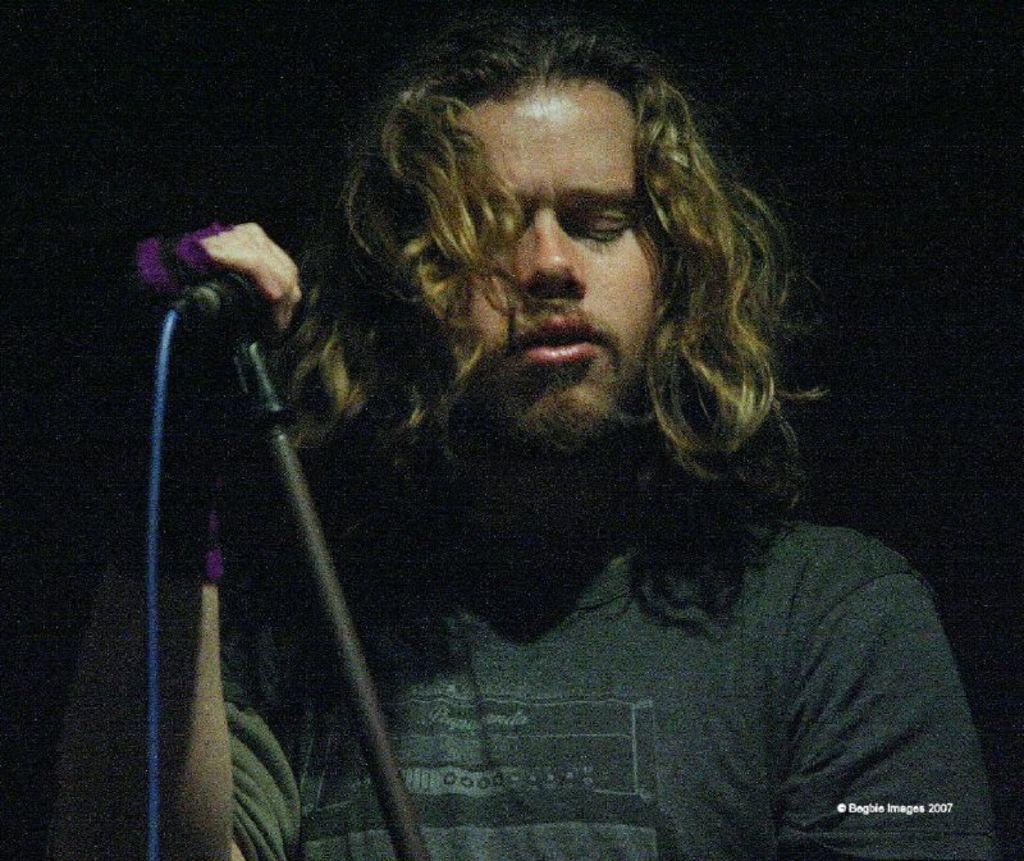Who is the main subject in the image? There is a man in the image. What is the man wearing? The man is wearing a black t-shirt. Can you describe the man's hairstyle? The man has blunt hair. What is the man holding in the image? The man is holding a mic. What type of teaching method is the man using in the image? There is no indication of teaching or any teaching method in the image; the man is holding a mic, which suggests he might be a performer or speaker. 